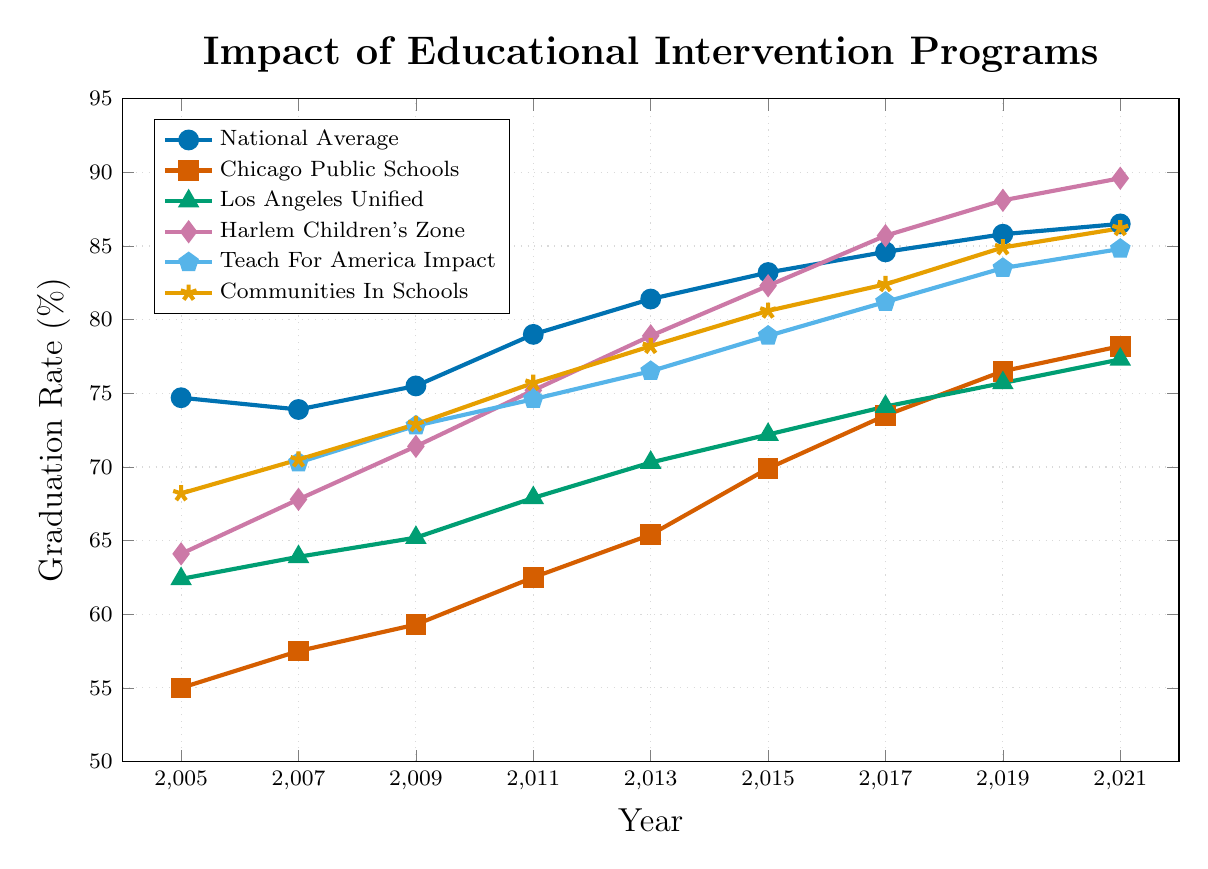What was the graduation rate for Harlem Children's Zone in 2021? Look at the data point corresponding to Harlem Children's Zone for the year 2021. The red diamond marker indicates this value.
Answer: 89.6% How did the graduation rate for Chicago Public Schools change from 2005 to 2021? Identify the values for Chicago Public Schools for the years 2005 and 2021 from the orange squares. The change is calculated as 78.2% (2021) - 55.0% (2005).
Answer: 23.2% Among the programs shown, which had the highest graduation rate in 2013? Compare the values for all the programs for the year 2013. Harlem Children's Zone has the highest value (78.9%) indicated by the red diamond.
Answer: Harlem Children's Zone What is the average graduation rate for Teach For America Impact from 2007 to 2021? Identify and sum the values for Teach For America Impact from 2007 to 2021, then divide by the number of years (8): (70.3 + 72.8 + 74.6 + 76.5 + 78.9 + 81.2 + 83.5 + 84.8) / 8.
Answer: 77.8% Which program showed the greatest increase in graduation rate between 2005 and 2021? Calculate the increase for each program from 2005 to 2021. Harlem Children's Zone increased from 64.1% to 89.6%, which is the greatest increase.
Answer: Harlem Children's Zone Did any programs exceed the national average graduation rate in 2021? Compare the graduation rates of all programs with the national average (86.5%) for 2021. Harlem Children's Zone and Communities In Schools exceed this rate.
Answer: Yes Which program had its graduation rate closest to the national average in 2019? Compare the graduation rates of all programs with the national average (85.8%) for 2019. Communities In Schools (84.9%) is the closest to the national average.
Answer: Communities In Schools In which year did Los Angeles Unified first exceed a graduation rate of 70%? Identify the years when Los Angeles Unified’s graduation rate surpasses 70%, marked by the green triangles. The first such year is 2013.
Answer: 2013 From 2005 to 2021, what is the overall trend observed in the graduation rates across all the programs? Examine the plotted curves for all programs from 2005 to 2021. All programs show an increasing trend in graduation rates over time.
Answer: Increasing trend Considering data up to 2021, which year had the smallest gap between the graduation rates of Chicago Public Schools and Los Angeles Unified? Subtract the graduation rates for Chicago Public Schools from Los Angeles Unified for each year and identify the smallest difference. The smallest gap is in 2021 with a difference of 0.9 percentage points (78.2% - 77.3%).
Answer: 2021 